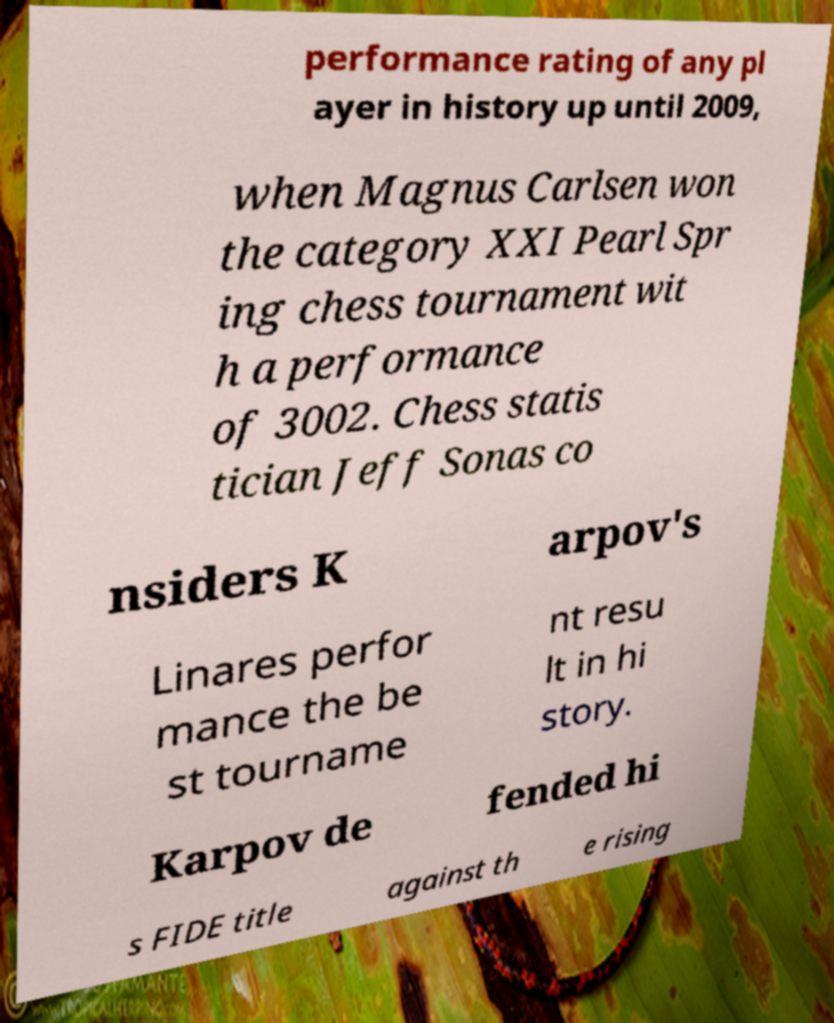I need the written content from this picture converted into text. Can you do that? performance rating of any pl ayer in history up until 2009, when Magnus Carlsen won the category XXI Pearl Spr ing chess tournament wit h a performance of 3002. Chess statis tician Jeff Sonas co nsiders K arpov's Linares perfor mance the be st tourname nt resu lt in hi story. Karpov de fended hi s FIDE title against th e rising 